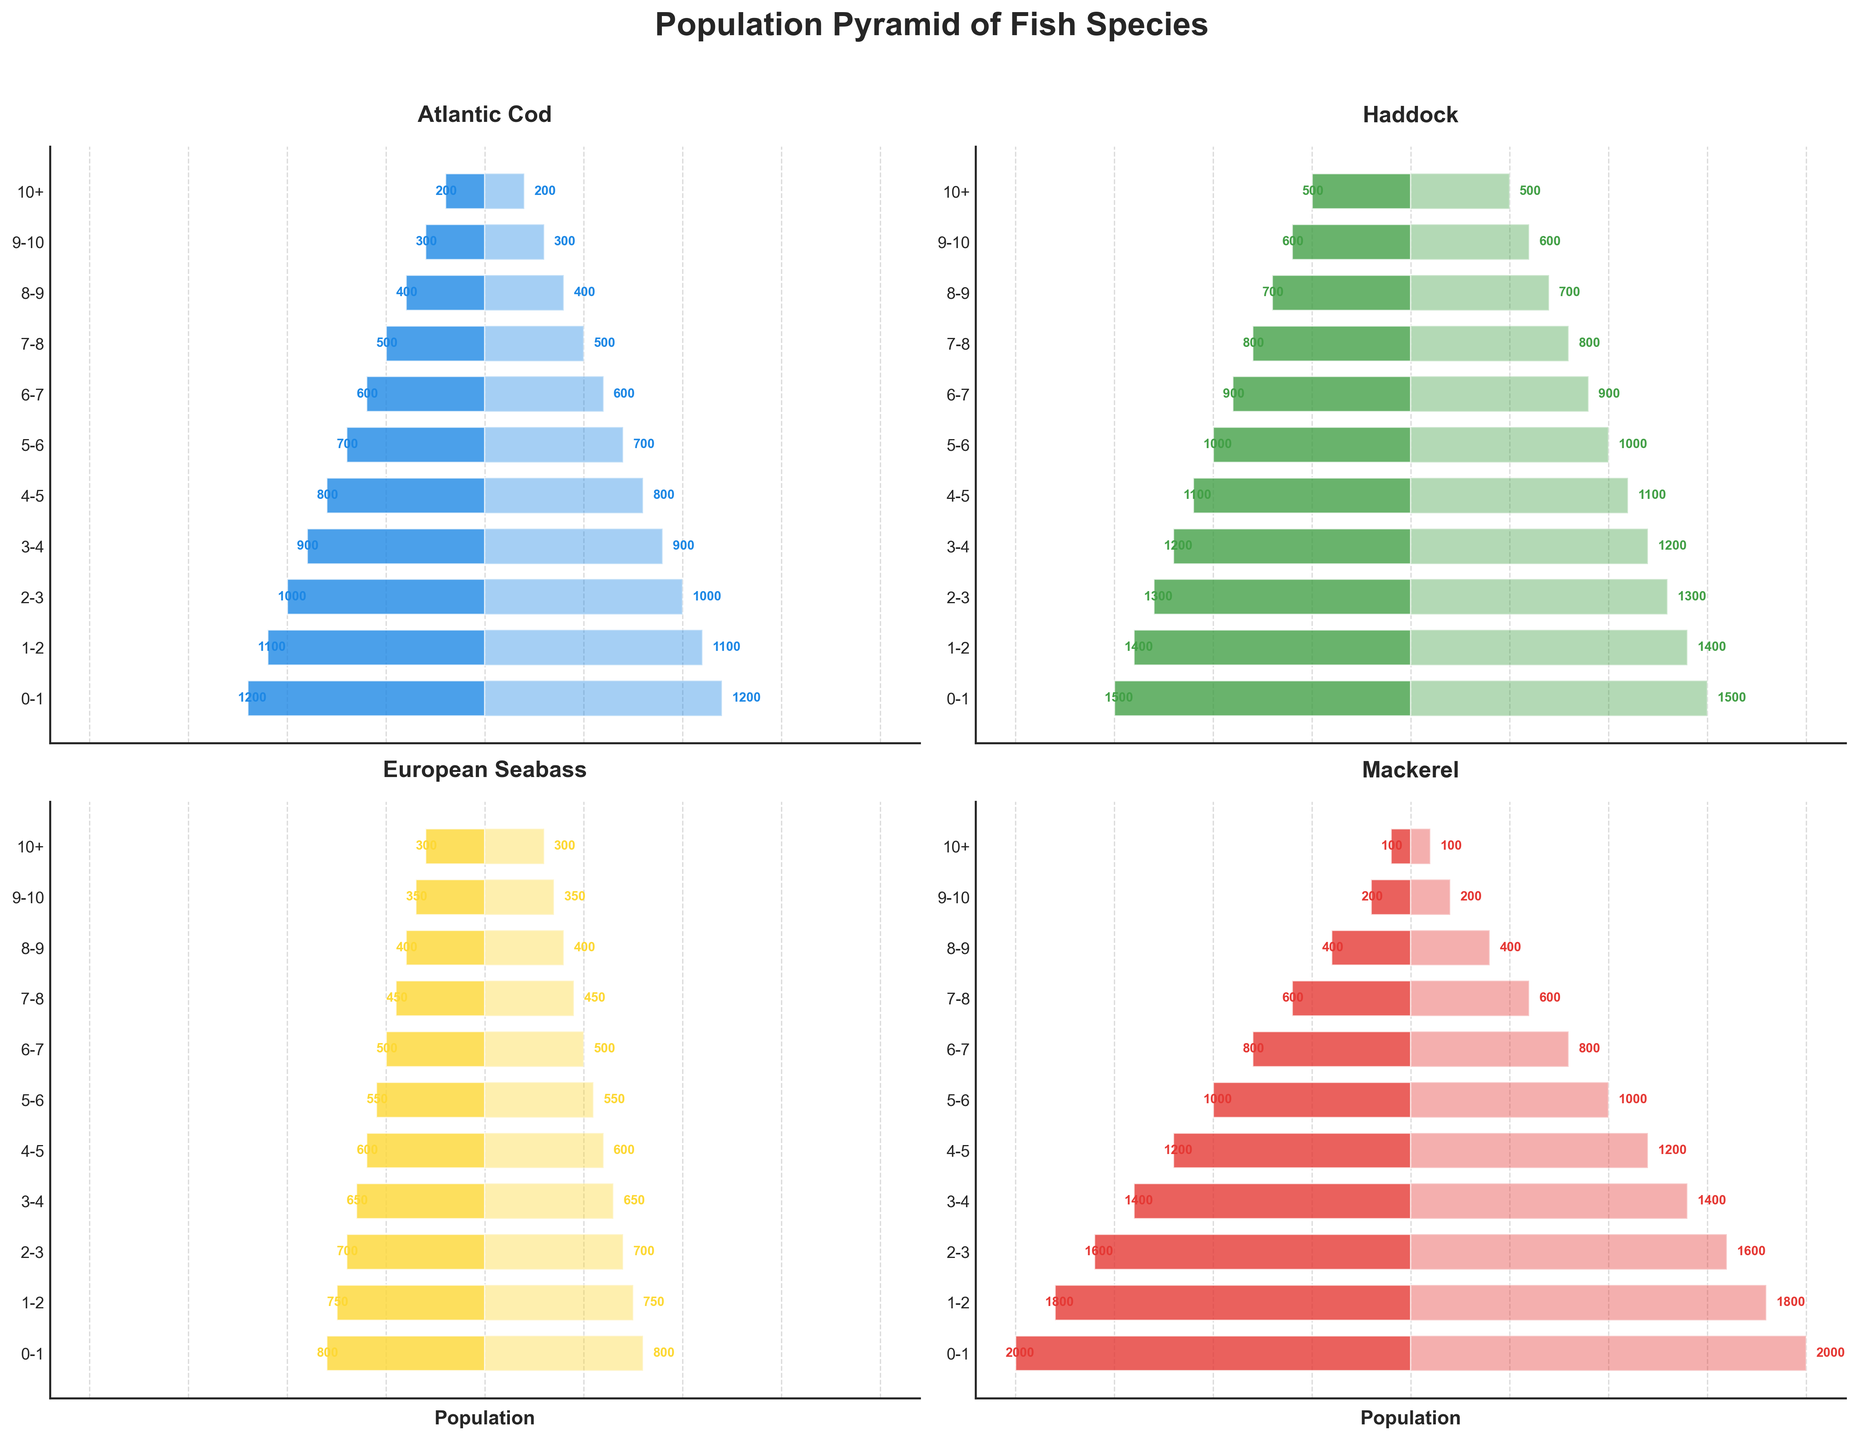Which age group has the highest population for Atlantic Cod? The graph shows the population of Atlantic Cod across various age groups. The age group with the tallest bar represents the age group with the highest population. Identifying the tallest bar for Atlantic Cod shows that the 0-1 age group has the highest population.
Answer: 0-1 Which species has the smallest population in the 10+ age group? By comparing the bar lengths for each species in the 10+ age group, it is evident that Mackerel has the smallest bar, indicating the smallest population.
Answer: Mackerel What is the total population of Haddock in all age groups combined? To find the total population, sum the populations of Haddock across all age groups: 1500 + 1400 + 1300 + 1200 + 1100 + 1000 + 900 + 800 + 700 + 600 + 500. The sum is 12000.
Answer: 12000 Which two species have a similar population trend as they age? Observing the bar patterns for each species, Atlantic Cod and Haddock have a similar declining trend as they age. Both species have higher populations in the younger age groups that gradually decrease in the older age groups.
Answer: Atlantic Cod and Haddock At what age do the European Seabass and Mackerel have the same population? Checking the alignment of bars for European Seabass and Mackerel, we see that the bars align at the age group 9-10, where both have populations of 350 and 200, respectively. However, on closer inspection, it's the age group 4-5 where both populations are quite close: Seabass at 600 and Mackerel at 1200.
Answer: 4-5 Which age group has a declining population trend across all species? By looking at the populations for each age group, the trend shows a declining population across all species as the age increases. A specific standout group is the 9-10 age group, where all species' populations are noticeably low compared to the younger age groups.
Answer: 9-10 What is the difference in population between the youngest and oldest age groups for Mackerel? To find the difference, subtract the population of the oldest age group (10+, which is 100) from the population of the youngest age group (0-1, which is 2000). The difference is 2000 - 100 = 1900.
Answer: 1900 Which species has the broadest distribution across age groups? By examining the range and distribution of the bars across age groups, Haddock appears to have the tallest bars spread out consistently across more age groups, indicating a broader distribution.
Answer: Haddock 